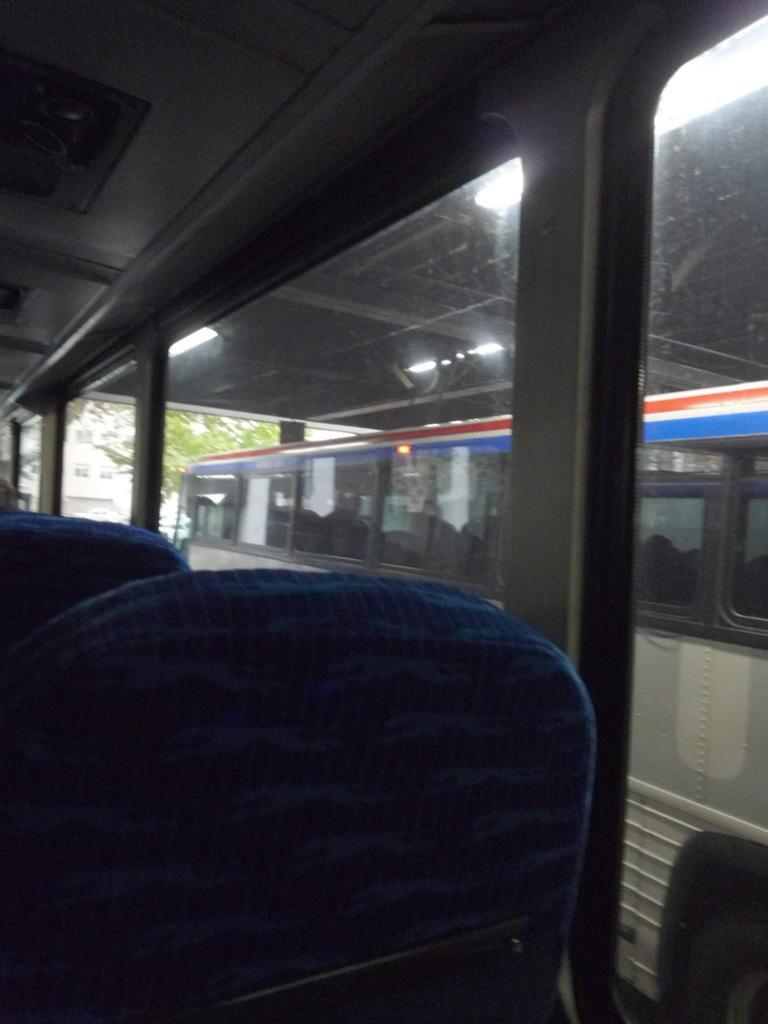Describe this image in one or two sentences. In this picture we can see a few vehicles on the path. There is a tree and a building in the background. 